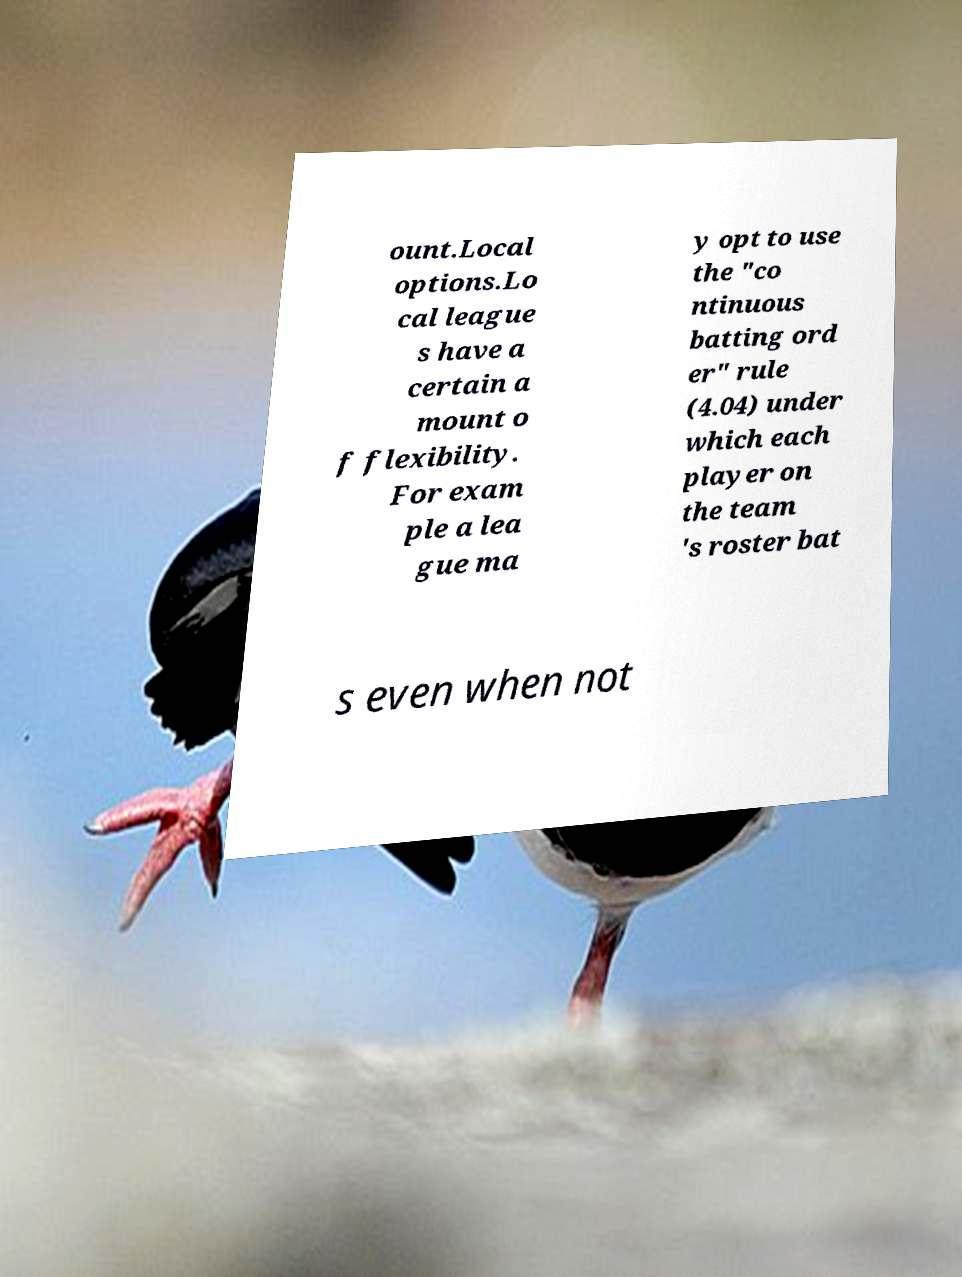Please identify and transcribe the text found in this image. ount.Local options.Lo cal league s have a certain a mount o f flexibility. For exam ple a lea gue ma y opt to use the "co ntinuous batting ord er" rule (4.04) under which each player on the team 's roster bat s even when not 